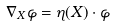<formula> <loc_0><loc_0><loc_500><loc_500>\nabla _ { X } \varphi = \eta ( X ) \cdot \varphi</formula> 